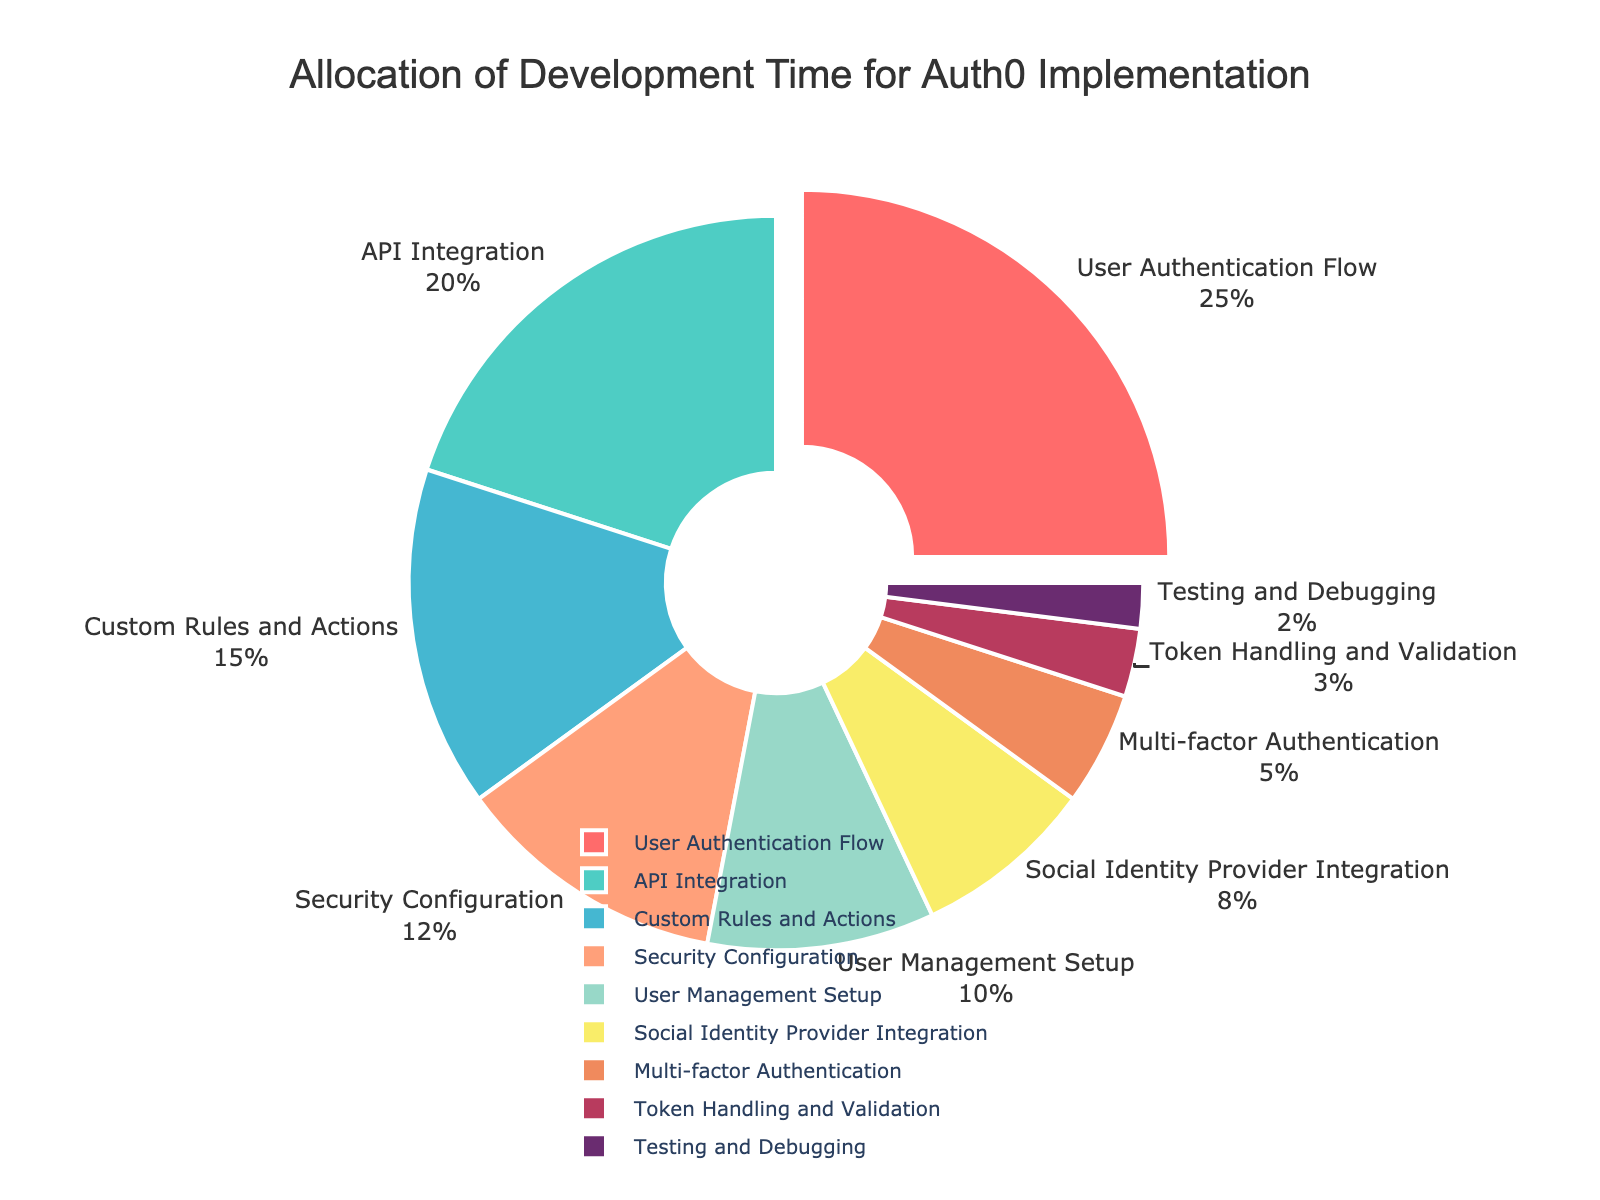Which category takes up the largest portion of development time? The User Authentication Flow category takes up the largest portion of the pie chart. This can be determined by observing that it is visually the biggest segment, which is also confirmed by the provided percentage data.
Answer: User Authentication Flow What is the combined percentage of time spent on API Integration and Custom Rules and Actions? To find the combined percentage, add the percentages for API Integration and Custom Rules and Actions (20% + 15%).
Answer: 35% Is User Management Setup allocated more or less time than Security Configuration? Compare the percentages of User Management Setup (10%) and Security Configuration (12%). User Management Setup has a smaller percentage than Security Configuration.
Answer: Less Which category is the smallest in terms of percentage allocation? The category with the smallest segment visually is Testing and Debugging, which is confirmed by its percentage (2%).
Answer: Testing and Debugging How much more time is spent on User Authentication Flow compared to Multi-factor Authentication? Subtract the percentage for Multi-factor Authentication (5%) from that for User Authentication Flow (25%) to find the difference.
Answer: 20% What percentage of development time is allocated to Security Configuration and Multi-factor Authentication combined? Add the percentages for Security Configuration (12%) and Multi-factor Authentication (5%) to get the combined percentage.
Answer: 17% Which is greater, the percentage for Social Identity Provider Integration or Token Handling and Validation? Compare the percentages for Social Identity Provider Integration (8%) and Token Handling and Validation (3%), and see that Social Identity Provider Integration is greater.
Answer: Social Identity Provider Integration What percentage of the total time is spent on categories other than API Integration? Subtract the percentage for API Integration (20%) from 100%, since the entire pie chart equals 100%.
Answer: 80% Which two categories together take up the largest portion of development time? The two largest categories individually are User Authentication Flow (25%) and API Integration (20%). Their combined percentage (25% + 20%) is 45%, which is higher than the combined percentages of any other pair.
Answer: User Authentication Flow and API Integration How does the time allocated for Custom Rules and Actions compare to the time allocated for User Management Setup and API Integration combined? Add the percentages for User Management Setup (10%) and API Integration (20%) to get a combined percentage of 30%. The percentage for Custom Rules and Actions is 15%. Compare to see that Custom Rules and Actions (15%) is less than the combined 30% for User Management Setup and API Integration.
Answer: Less 